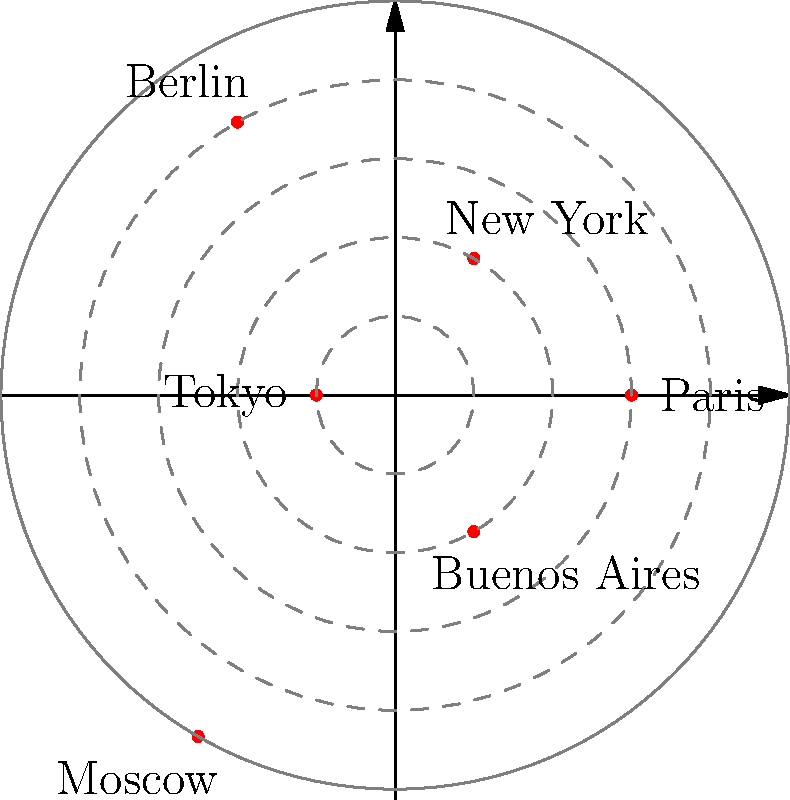In the polar coordinate graph representing the geographical distribution of overlooked 20th-century artists, which city has the highest concentration of such artists, and what does this imply about the artistic landscape of that era? To answer this question, we need to analyze the polar coordinate graph:

1. The graph shows six cities: Paris, New York, Berlin, Tokyo, Moscow, and Buenos Aires.
2. Each city is represented by a point on the graph, where the angle represents its location and the radius represents the concentration of overlooked 20th-century artists.
3. The farther a point is from the center, the higher the concentration of artists.
4. Examining the graph, we can see that:
   - Paris is at approximately $r = 3$
   - New York is at $r = 2$
   - Berlin is at $r = 4$
   - Tokyo is at $r = 1$
   - Moscow is at $r = 5$
   - Buenos Aires is at $r = 2$
5. Moscow has the highest radius value at $r = 5$, indicating the highest concentration of overlooked 20th-century artists.
6. This implies that Moscow had a vibrant but potentially underappreciated artistic community during the 20th century.
7. The high concentration in Moscow could be due to various factors, such as:
   - Political and social conditions that may have limited international exposure
   - A rich cultural scene that was overshadowed by Western-centric art histories
   - The presence of avant-garde movements that were not fully recognized globally at the time

This finding challenges the traditional narrative of 20th-century art history, which often focuses on Western European and American artistic centers, and highlights the importance of exploring overlooked artistic communities in less frequently studied locations.
Answer: Moscow; indicates a significant but underrecognized artistic community. 